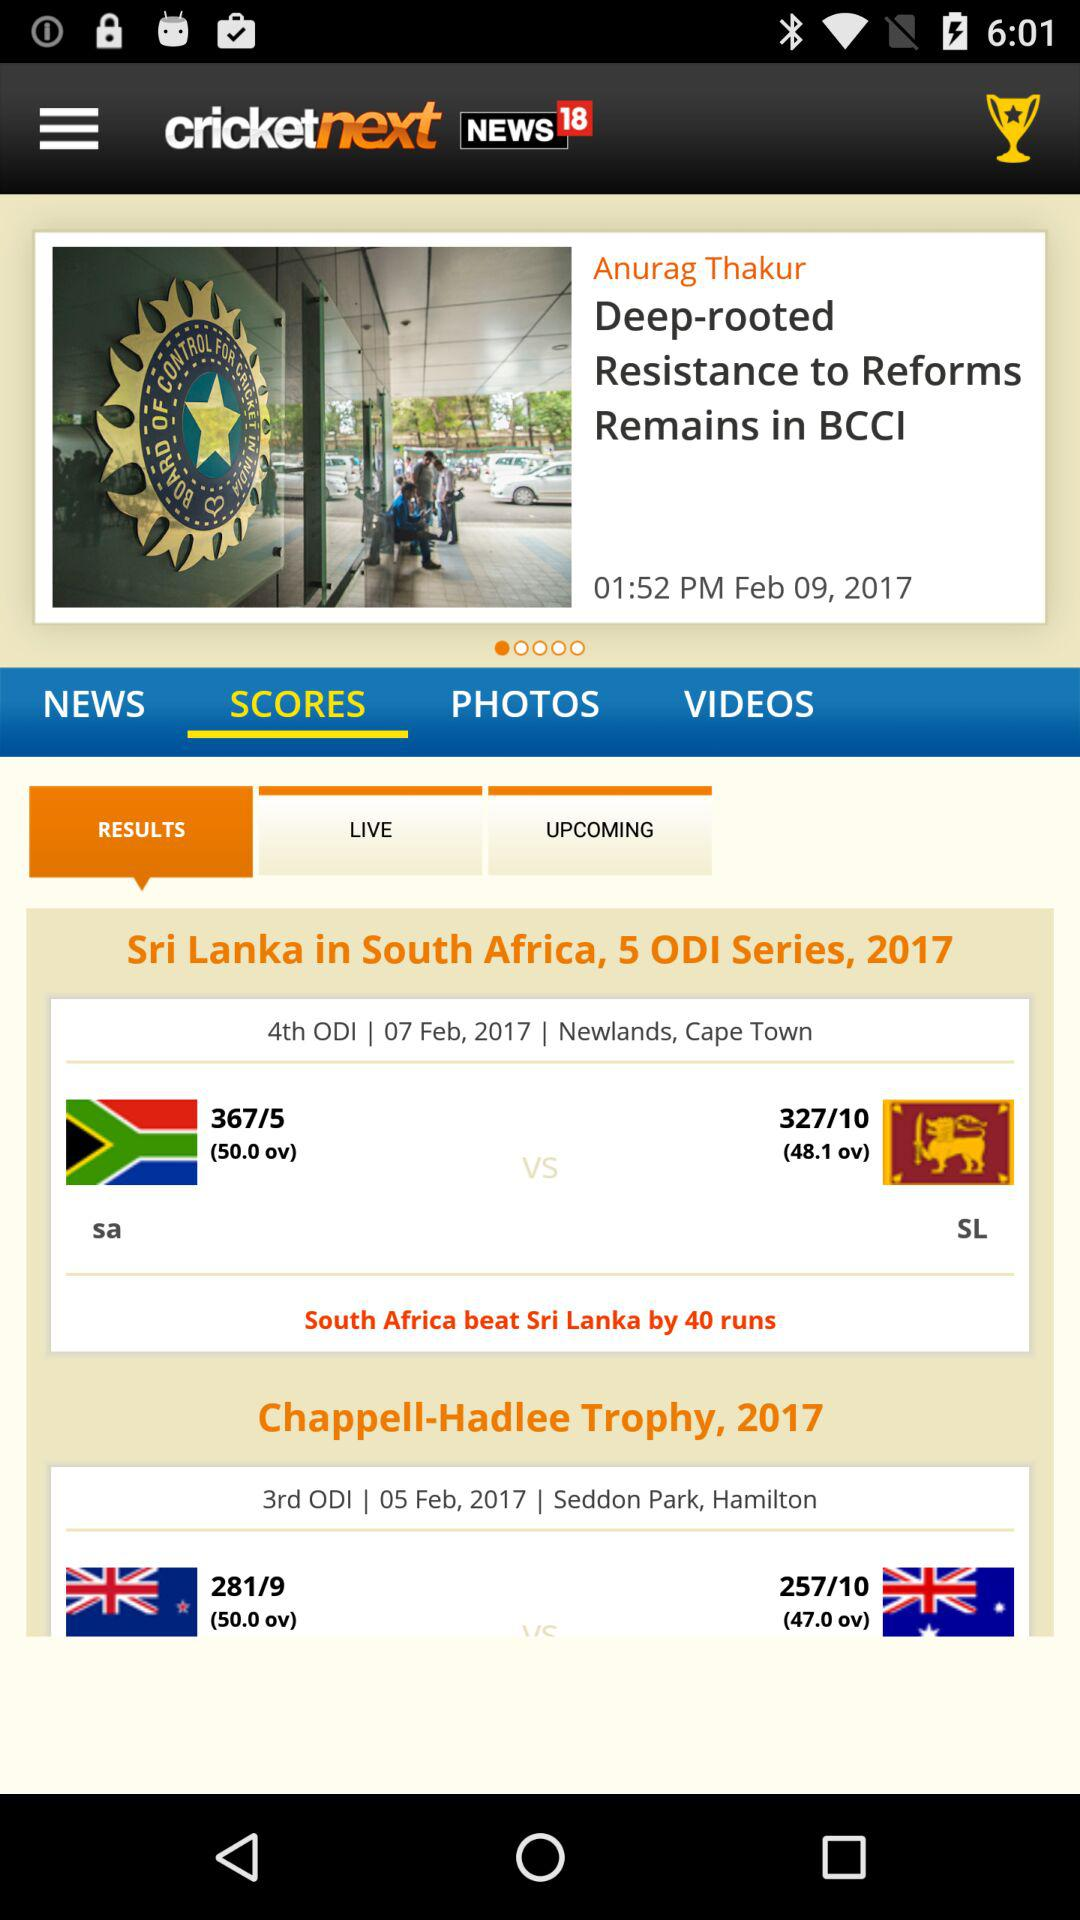Who is the author of the article "Deep-rooted Resistance to Reforms Remains in BCCI"? The author of the article "Deep-rooted Resistance to Reforms Remains in BCCI" is Anurag Thakur. 